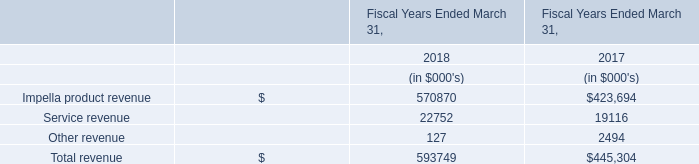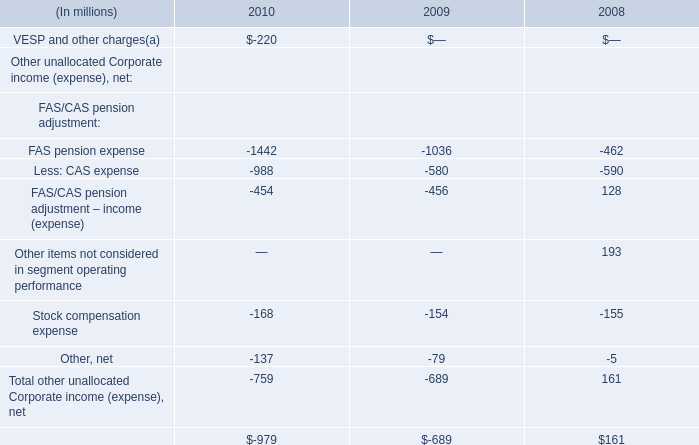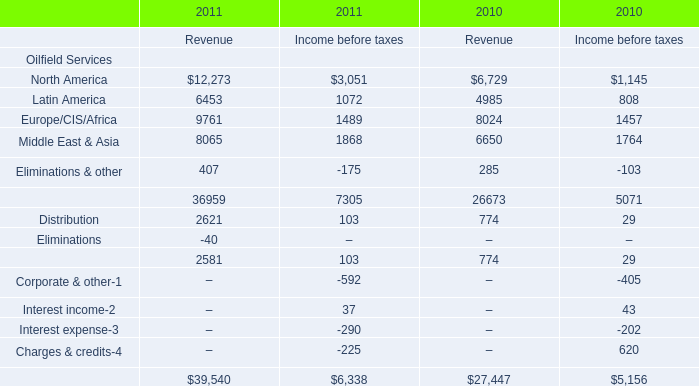In the year with largest amount of North America what's the increasing rate of Middle East & Asia ? 
Computations: ((((8065 + 1868) - 6650) - 1764) / (8065 + 1868))
Answer: 0.15292. 